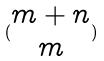<formula> <loc_0><loc_0><loc_500><loc_500>( \begin{matrix} m + n \\ m \end{matrix} )</formula> 